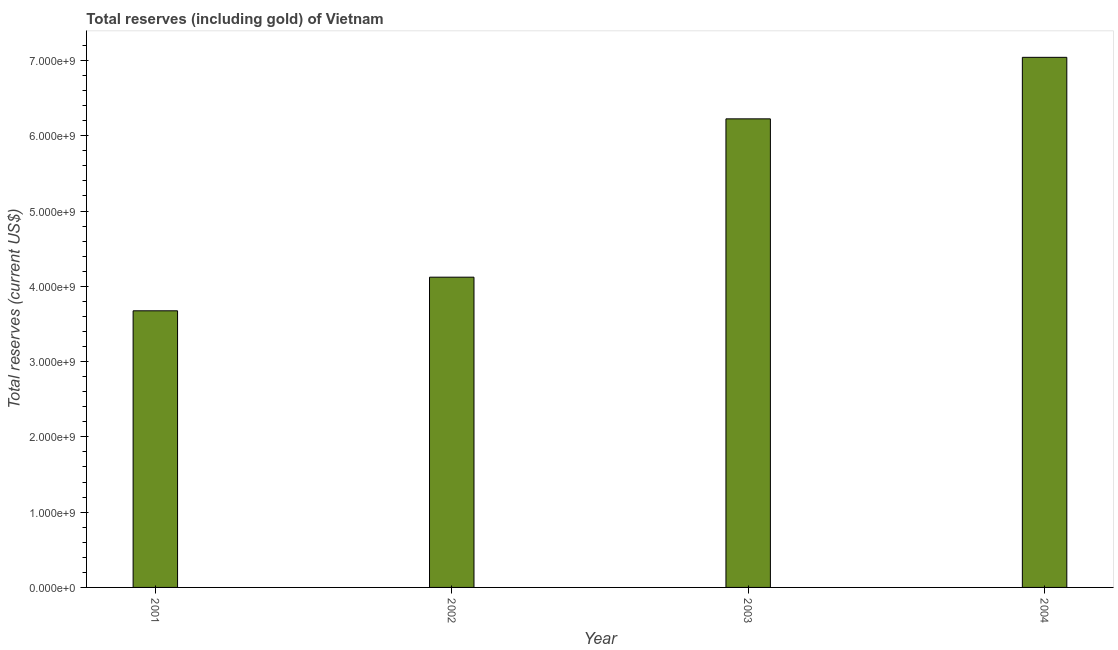Does the graph contain any zero values?
Keep it short and to the point. No. Does the graph contain grids?
Provide a short and direct response. No. What is the title of the graph?
Ensure brevity in your answer.  Total reserves (including gold) of Vietnam. What is the label or title of the Y-axis?
Offer a terse response. Total reserves (current US$). What is the total reserves (including gold) in 2002?
Make the answer very short. 4.12e+09. Across all years, what is the maximum total reserves (including gold)?
Your answer should be compact. 7.04e+09. Across all years, what is the minimum total reserves (including gold)?
Your answer should be compact. 3.67e+09. In which year was the total reserves (including gold) maximum?
Provide a short and direct response. 2004. What is the sum of the total reserves (including gold)?
Your answer should be compact. 2.11e+1. What is the difference between the total reserves (including gold) in 2003 and 2004?
Provide a succinct answer. -8.17e+08. What is the average total reserves (including gold) per year?
Offer a terse response. 5.27e+09. What is the median total reserves (including gold)?
Offer a very short reply. 5.17e+09. In how many years, is the total reserves (including gold) greater than 200000000 US$?
Provide a short and direct response. 4. What is the ratio of the total reserves (including gold) in 2001 to that in 2003?
Ensure brevity in your answer.  0.59. Is the total reserves (including gold) in 2002 less than that in 2004?
Your answer should be very brief. Yes. What is the difference between the highest and the second highest total reserves (including gold)?
Your answer should be compact. 8.17e+08. What is the difference between the highest and the lowest total reserves (including gold)?
Offer a very short reply. 3.37e+09. Are the values on the major ticks of Y-axis written in scientific E-notation?
Provide a short and direct response. Yes. What is the Total reserves (current US$) of 2001?
Your answer should be compact. 3.67e+09. What is the Total reserves (current US$) of 2002?
Make the answer very short. 4.12e+09. What is the Total reserves (current US$) in 2003?
Provide a short and direct response. 6.22e+09. What is the Total reserves (current US$) of 2004?
Offer a very short reply. 7.04e+09. What is the difference between the Total reserves (current US$) in 2001 and 2002?
Offer a very short reply. -4.46e+08. What is the difference between the Total reserves (current US$) in 2001 and 2003?
Provide a short and direct response. -2.55e+09. What is the difference between the Total reserves (current US$) in 2001 and 2004?
Ensure brevity in your answer.  -3.37e+09. What is the difference between the Total reserves (current US$) in 2002 and 2003?
Your answer should be compact. -2.10e+09. What is the difference between the Total reserves (current US$) in 2002 and 2004?
Your answer should be compact. -2.92e+09. What is the difference between the Total reserves (current US$) in 2003 and 2004?
Give a very brief answer. -8.17e+08. What is the ratio of the Total reserves (current US$) in 2001 to that in 2002?
Ensure brevity in your answer.  0.89. What is the ratio of the Total reserves (current US$) in 2001 to that in 2003?
Make the answer very short. 0.59. What is the ratio of the Total reserves (current US$) in 2001 to that in 2004?
Provide a succinct answer. 0.52. What is the ratio of the Total reserves (current US$) in 2002 to that in 2003?
Your answer should be very brief. 0.66. What is the ratio of the Total reserves (current US$) in 2002 to that in 2004?
Your answer should be very brief. 0.58. What is the ratio of the Total reserves (current US$) in 2003 to that in 2004?
Ensure brevity in your answer.  0.88. 